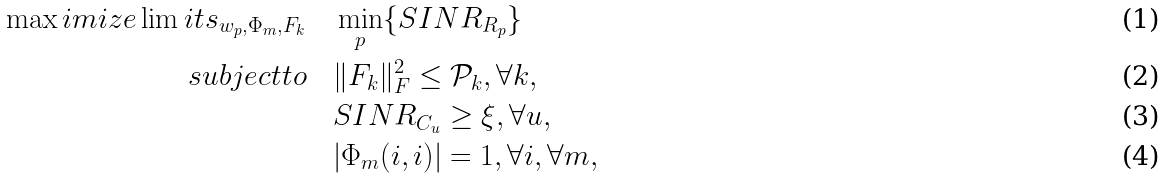Convert formula to latex. <formula><loc_0><loc_0><loc_500><loc_500>{ \max i m i z e } \lim i t s _ { { w } _ { p } , { \Phi } _ { m } , { F } _ { k } } & { \quad } \min _ { p } \{ S I N R _ { R _ { p } } \} \\ s u b j e c t t o & { \quad } \| { F } _ { k } \| _ { F } ^ { 2 } \leq \mathcal { P } _ { k } , \forall k , \\ & { \quad } S I N R _ { C _ { u } } \geq \xi , \forall u , \\ & { \quad } | { \Phi } _ { m } ( i , i ) | = 1 , \forall i , \forall m ,</formula> 